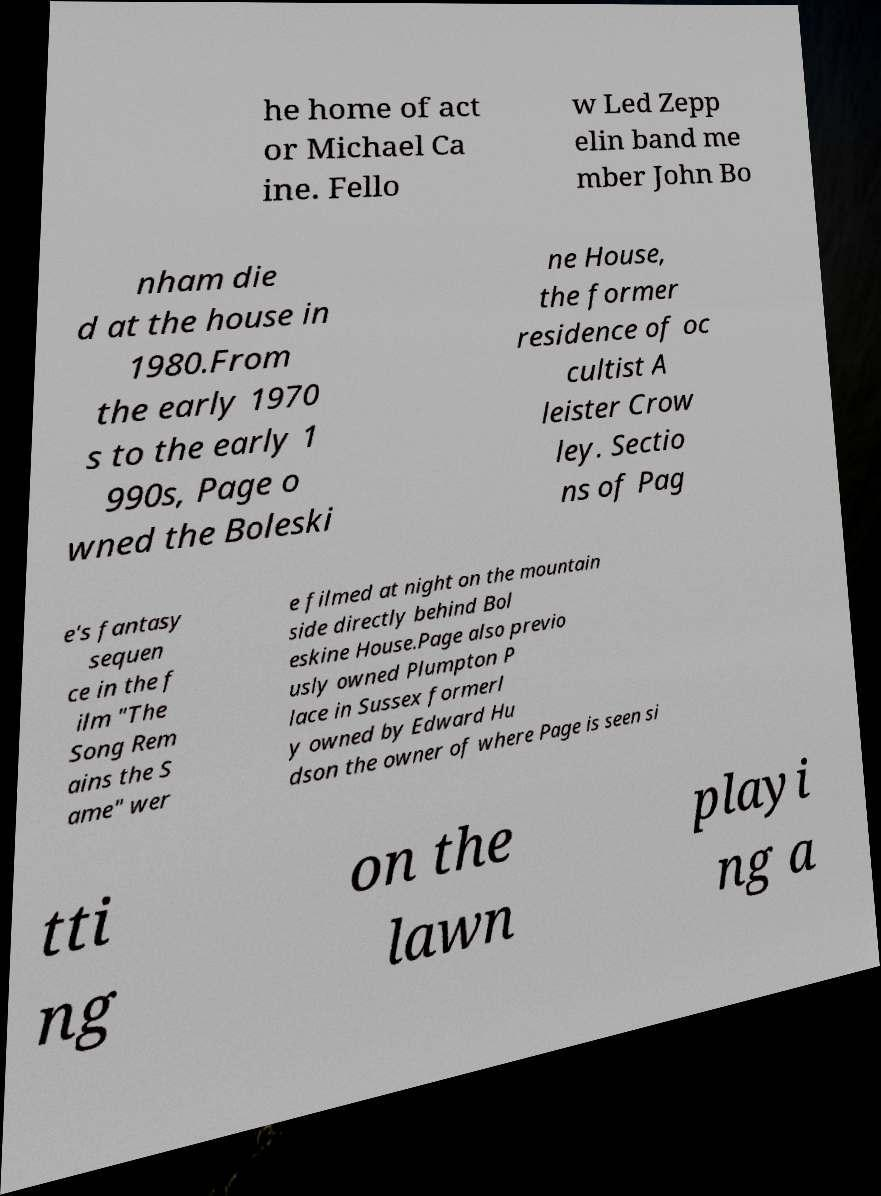I need the written content from this picture converted into text. Can you do that? he home of act or Michael Ca ine. Fello w Led Zepp elin band me mber John Bo nham die d at the house in 1980.From the early 1970 s to the early 1 990s, Page o wned the Boleski ne House, the former residence of oc cultist A leister Crow ley. Sectio ns of Pag e's fantasy sequen ce in the f ilm "The Song Rem ains the S ame" wer e filmed at night on the mountain side directly behind Bol eskine House.Page also previo usly owned Plumpton P lace in Sussex formerl y owned by Edward Hu dson the owner of where Page is seen si tti ng on the lawn playi ng a 